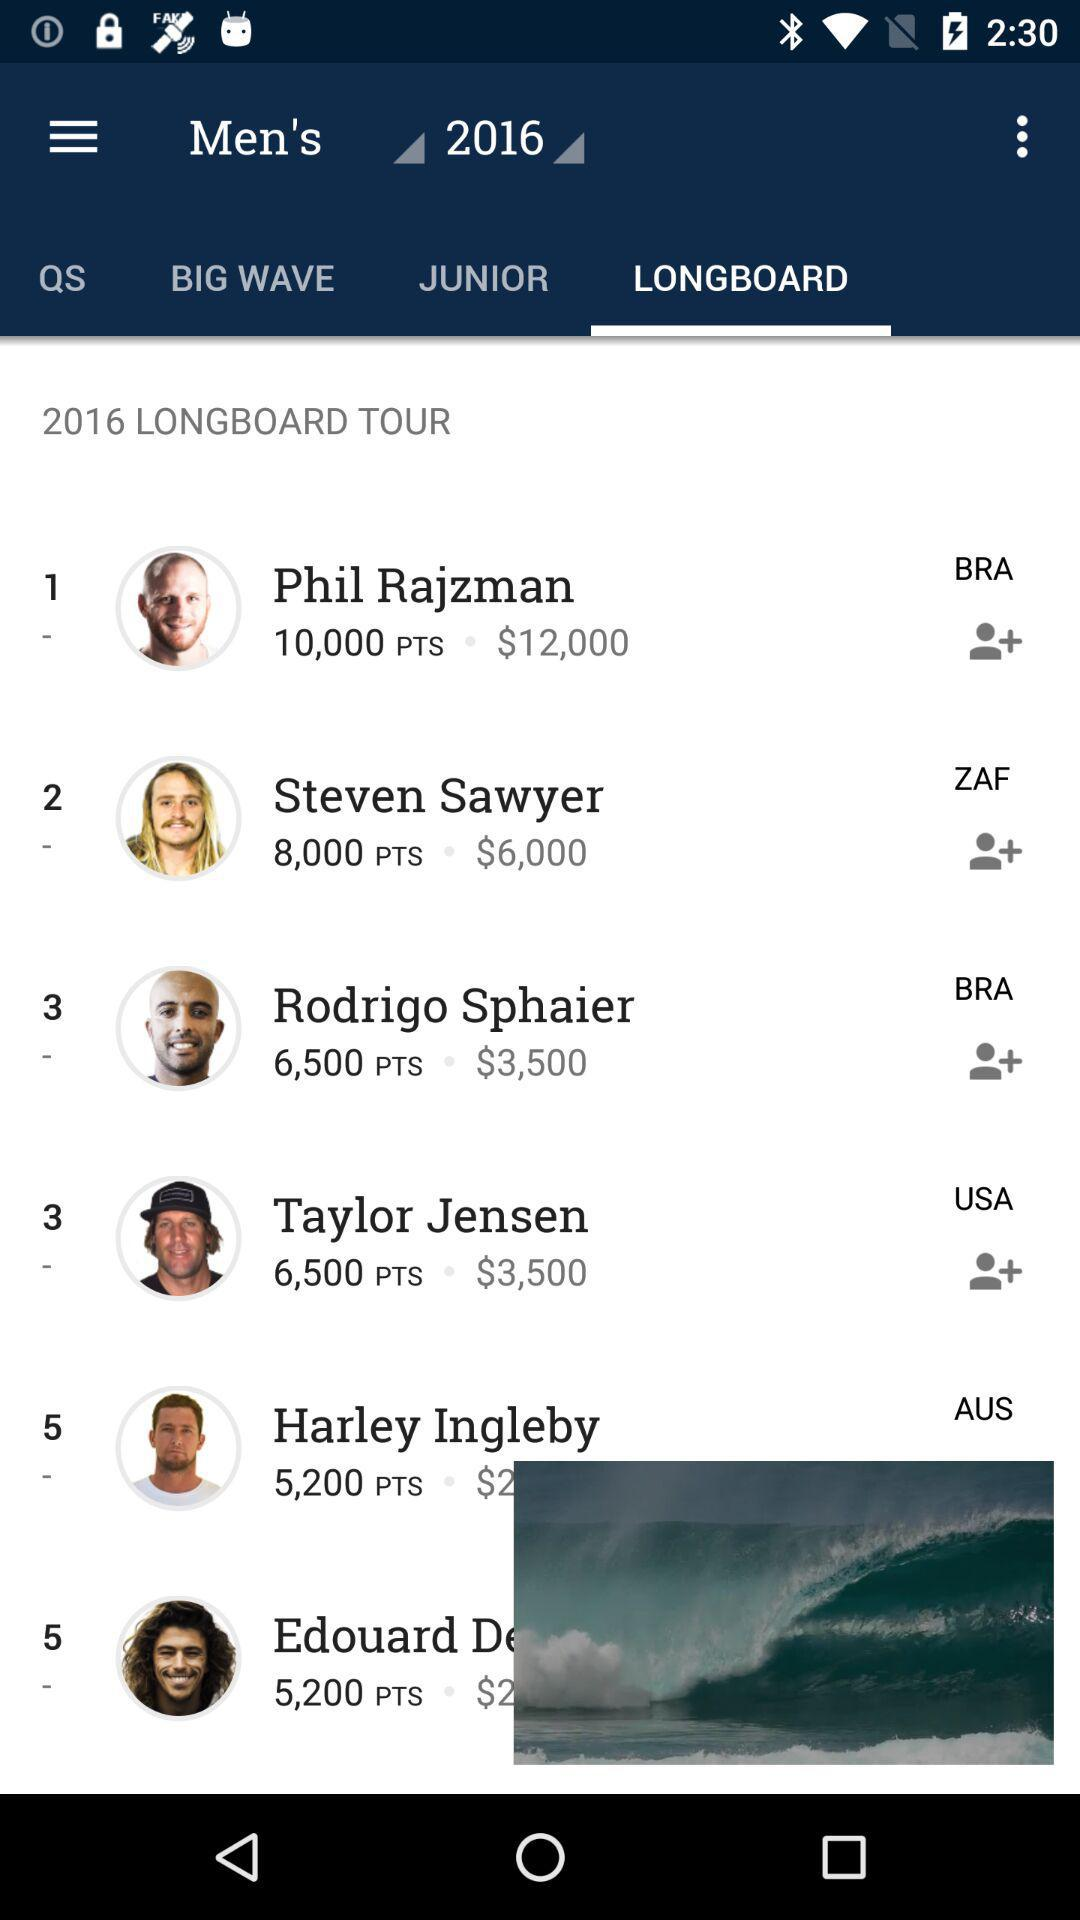Who has 8000 points? The one who has 8000 points is Steven Sawyer. 